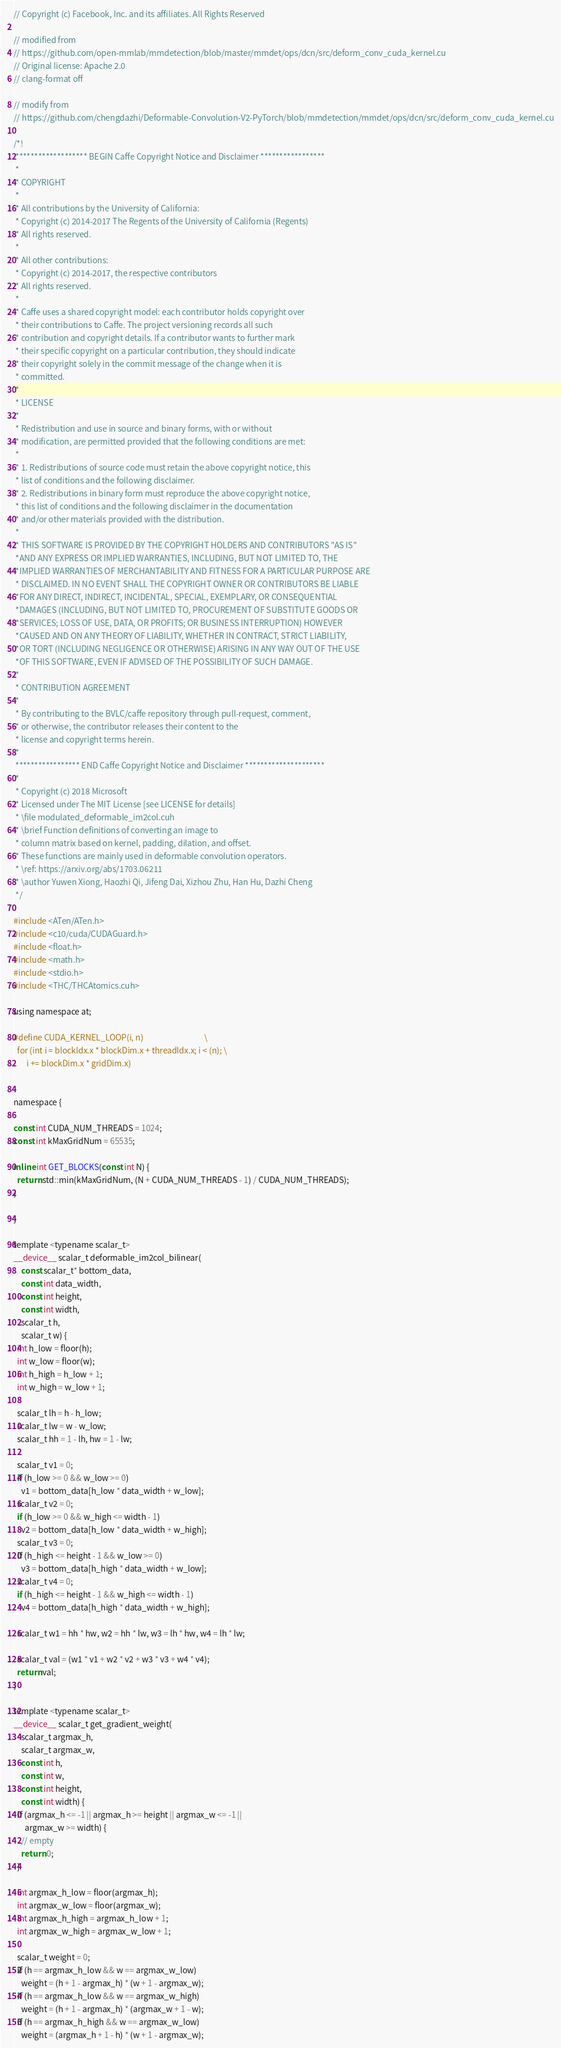<code> <loc_0><loc_0><loc_500><loc_500><_Cuda_>// Copyright (c) Facebook, Inc. and its affiliates. All Rights Reserved

// modified from
// https://github.com/open-mmlab/mmdetection/blob/master/mmdet/ops/dcn/src/deform_conv_cuda_kernel.cu
// Original license: Apache 2.0
// clang-format off

// modify from
// https://github.com/chengdazhi/Deformable-Convolution-V2-PyTorch/blob/mmdetection/mmdet/ops/dcn/src/deform_conv_cuda_kernel.cu

/*!
 ******************* BEGIN Caffe Copyright Notice and Disclaimer *****************
 *
 * COPYRIGHT
 *
 * All contributions by the University of California:
 * Copyright (c) 2014-2017 The Regents of the University of California (Regents)
 * All rights reserved.
 *
 * All other contributions:
 * Copyright (c) 2014-2017, the respective contributors
 * All rights reserved.
 *
 * Caffe uses a shared copyright model: each contributor holds copyright over
 * their contributions to Caffe. The project versioning records all such
 * contribution and copyright details. If a contributor wants to further mark
 * their specific copyright on a particular contribution, they should indicate
 * their copyright solely in the commit message of the change when it is
 * committed.
 *
 * LICENSE
 *
 * Redistribution and use in source and binary forms, with or without
 * modification, are permitted provided that the following conditions are met:
 *
 * 1. Redistributions of source code must retain the above copyright notice, this
 * list of conditions and the following disclaimer.
 * 2. Redistributions in binary form must reproduce the above copyright notice,
 * this list of conditions and the following disclaimer in the documentation
 * and/or other materials provided with the distribution.
 *
 * THIS SOFTWARE IS PROVIDED BY THE COPYRIGHT HOLDERS AND CONTRIBUTORS "AS IS"
 *AND ANY EXPRESS OR IMPLIED WARRANTIES, INCLUDING, BUT NOT LIMITED TO, THE
 *IMPLIED WARRANTIES OF MERCHANTABILITY AND FITNESS FOR A PARTICULAR PURPOSE ARE
 * DISCLAIMED. IN NO EVENT SHALL THE COPYRIGHT OWNER OR CONTRIBUTORS BE LIABLE
 *FOR ANY DIRECT, INDIRECT, INCIDENTAL, SPECIAL, EXEMPLARY, OR CONSEQUENTIAL
 *DAMAGES (INCLUDING, BUT NOT LIMITED TO, PROCUREMENT OF SUBSTITUTE GOODS OR
 *SERVICES; LOSS OF USE, DATA, OR PROFITS; OR BUSINESS INTERRUPTION) HOWEVER
 *CAUSED AND ON ANY THEORY OF LIABILITY, WHETHER IN CONTRACT, STRICT LIABILITY,
 *OR TORT (INCLUDING NEGLIGENCE OR OTHERWISE) ARISING IN ANY WAY OUT OF THE USE
 *OF THIS SOFTWARE, EVEN IF ADVISED OF THE POSSIBILITY OF SUCH DAMAGE.
 *
 * CONTRIBUTION AGREEMENT
 *
 * By contributing to the BVLC/caffe repository through pull-request, comment,
 * or otherwise, the contributor releases their content to the
 * license and copyright terms herein.
 *
 ***************** END Caffe Copyright Notice and Disclaimer *********************
 *
 * Copyright (c) 2018 Microsoft
 * Licensed under The MIT License [see LICENSE for details]
 * \file modulated_deformable_im2col.cuh
 * \brief Function definitions of converting an image to
 * column matrix based on kernel, padding, dilation, and offset.
 * These functions are mainly used in deformable convolution operators.
 * \ref: https://arxiv.org/abs/1703.06211
 * \author Yuwen Xiong, Haozhi Qi, Jifeng Dai, Xizhou Zhu, Han Hu, Dazhi Cheng
 */

#include <ATen/ATen.h>
#include <c10/cuda/CUDAGuard.h>
#include <float.h>
#include <math.h>
#include <stdio.h>
#include <THC/THCAtomics.cuh>

using namespace at;

#define CUDA_KERNEL_LOOP(i, n)                                 \
  for (int i = blockIdx.x * blockDim.x + threadIdx.x; i < (n); \
       i += blockDim.x * gridDim.x)


namespace {

const int CUDA_NUM_THREADS = 1024;
const int kMaxGridNum = 65535;

inline int GET_BLOCKS(const int N) {
  return std::min(kMaxGridNum, (N + CUDA_NUM_THREADS - 1) / CUDA_NUM_THREADS);
}

}

template <typename scalar_t>
__device__ scalar_t deformable_im2col_bilinear(
    const scalar_t* bottom_data,
    const int data_width,
    const int height,
    const int width,
    scalar_t h,
    scalar_t w) {
  int h_low = floor(h);
  int w_low = floor(w);
  int h_high = h_low + 1;
  int w_high = w_low + 1;

  scalar_t lh = h - h_low;
  scalar_t lw = w - w_low;
  scalar_t hh = 1 - lh, hw = 1 - lw;

  scalar_t v1 = 0;
  if (h_low >= 0 && w_low >= 0)
    v1 = bottom_data[h_low * data_width + w_low];
  scalar_t v2 = 0;
  if (h_low >= 0 && w_high <= width - 1)
    v2 = bottom_data[h_low * data_width + w_high];
  scalar_t v3 = 0;
  if (h_high <= height - 1 && w_low >= 0)
    v3 = bottom_data[h_high * data_width + w_low];
  scalar_t v4 = 0;
  if (h_high <= height - 1 && w_high <= width - 1)
    v4 = bottom_data[h_high * data_width + w_high];

  scalar_t w1 = hh * hw, w2 = hh * lw, w3 = lh * hw, w4 = lh * lw;

  scalar_t val = (w1 * v1 + w2 * v2 + w3 * v3 + w4 * v4);
  return val;
}

template <typename scalar_t>
__device__ scalar_t get_gradient_weight(
    scalar_t argmax_h,
    scalar_t argmax_w,
    const int h,
    const int w,
    const int height,
    const int width) {
  if (argmax_h <= -1 || argmax_h >= height || argmax_w <= -1 ||
      argmax_w >= width) {
    // empty
    return 0;
  }

  int argmax_h_low = floor(argmax_h);
  int argmax_w_low = floor(argmax_w);
  int argmax_h_high = argmax_h_low + 1;
  int argmax_w_high = argmax_w_low + 1;

  scalar_t weight = 0;
  if (h == argmax_h_low && w == argmax_w_low)
    weight = (h + 1 - argmax_h) * (w + 1 - argmax_w);
  if (h == argmax_h_low && w == argmax_w_high)
    weight = (h + 1 - argmax_h) * (argmax_w + 1 - w);
  if (h == argmax_h_high && w == argmax_w_low)
    weight = (argmax_h + 1 - h) * (w + 1 - argmax_w);</code> 